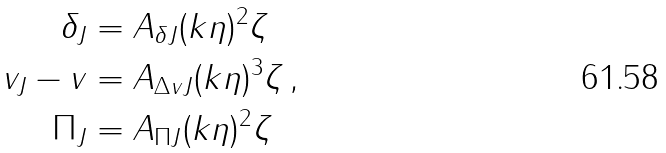<formula> <loc_0><loc_0><loc_500><loc_500>\delta _ { J } & = A _ { \delta J } ( k \eta ) ^ { 2 } \zeta \\ v _ { J } - v & = A _ { \Delta v J } ( k \eta ) ^ { 3 } \zeta \, , \\ \Pi _ { J } & = A _ { \Pi J } ( k \eta ) ^ { 2 } \zeta</formula> 